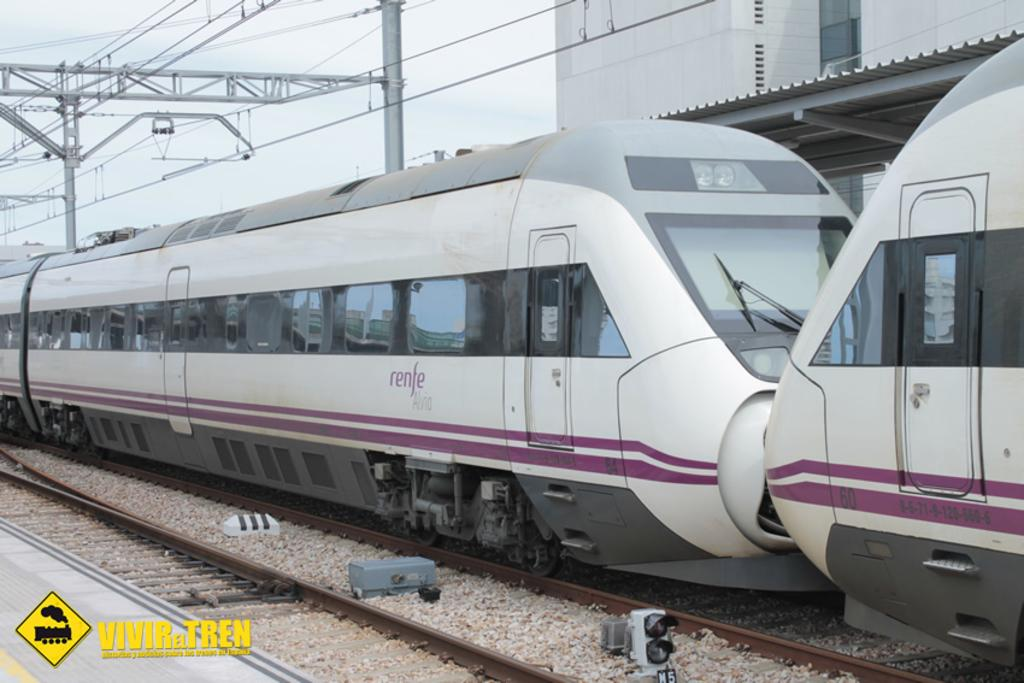Provide a one-sentence caption for the provided image. A pink train with the word renfe printed on the side. 